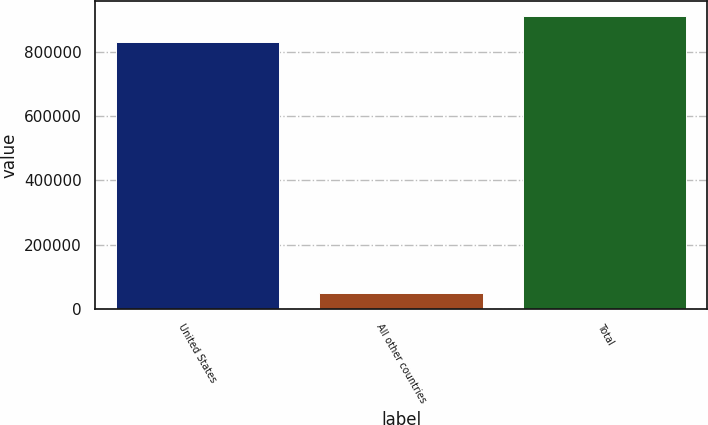<chart> <loc_0><loc_0><loc_500><loc_500><bar_chart><fcel>United States<fcel>All other countries<fcel>Total<nl><fcel>830060<fcel>49859<fcel>913066<nl></chart> 